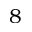Convert formula to latex. <formula><loc_0><loc_0><loc_500><loc_500>8</formula> 